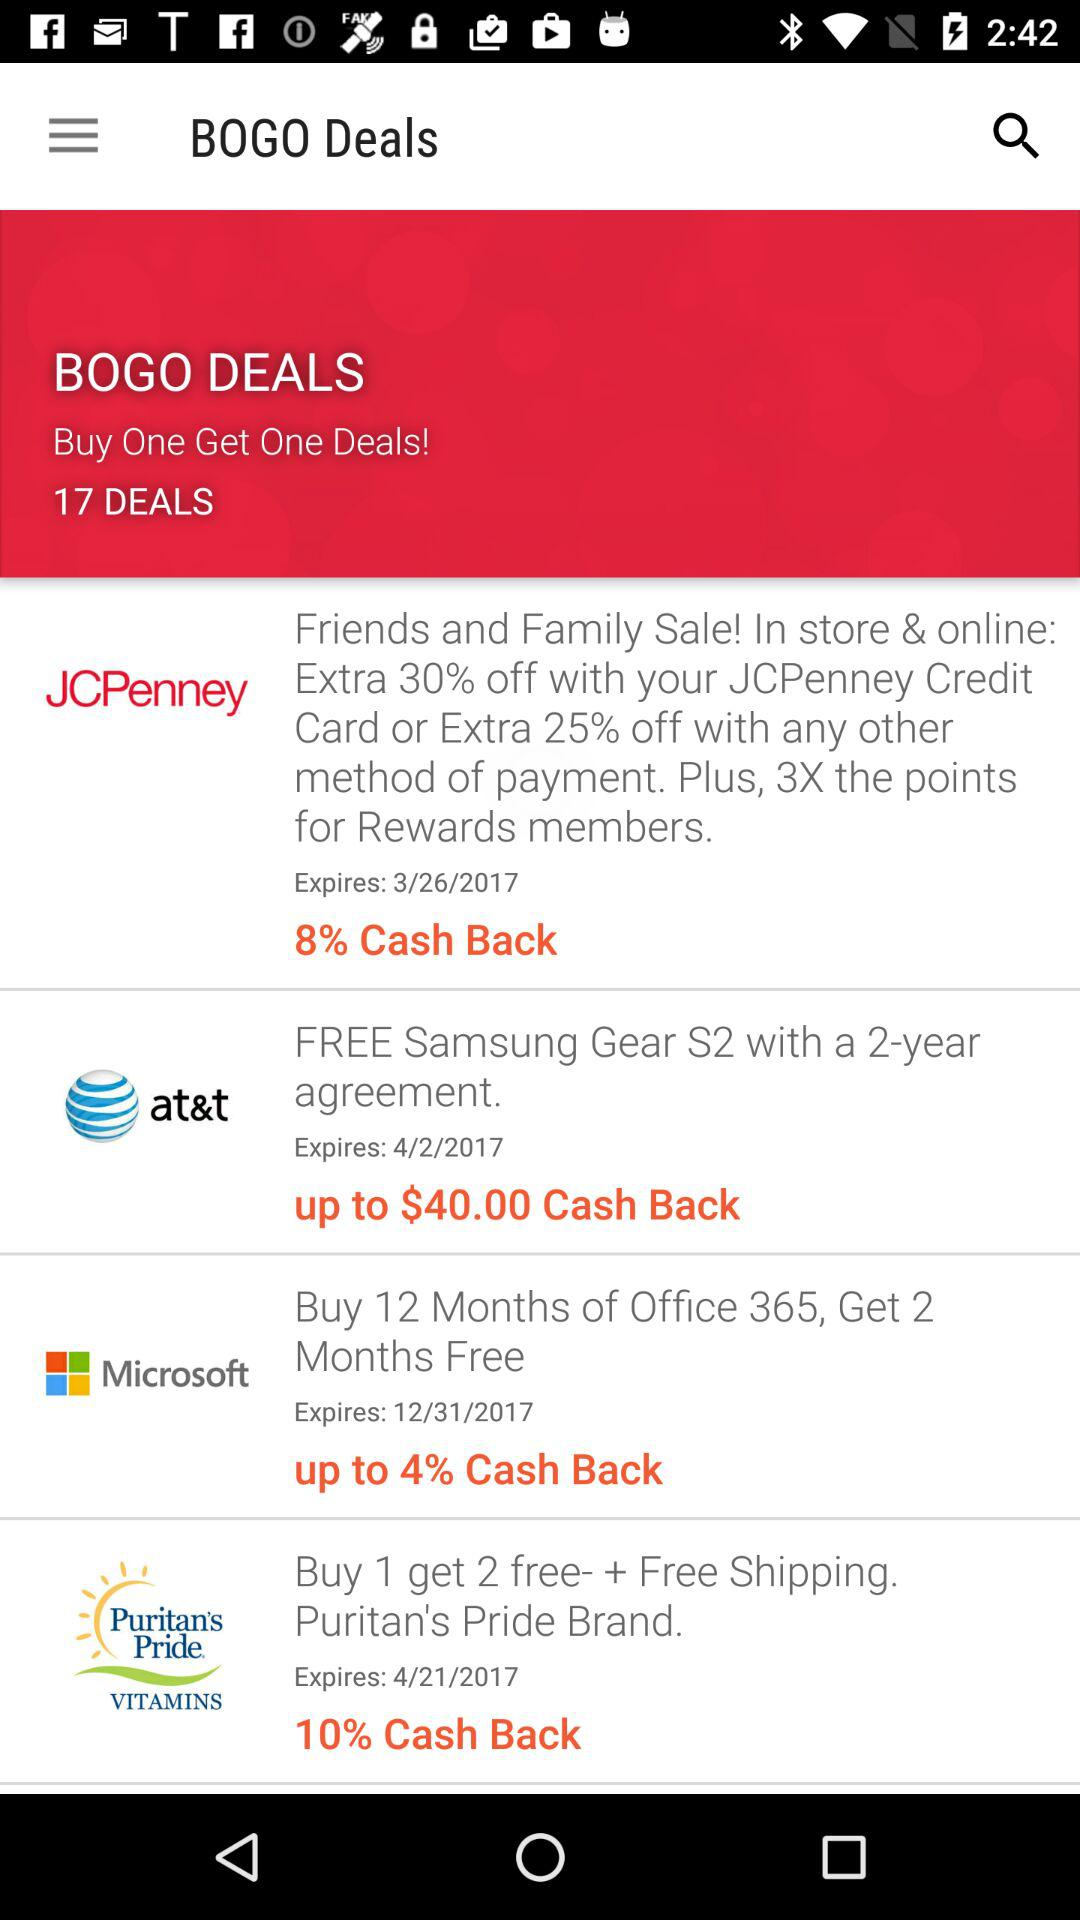Which offer in the image includes a free physical item? The AT&T offer includes a free Samsung Gear S2 with a 2-year agreement, as indicated in the image. Is this offer from AT&T still valid? If the current date is before or on the expiration date, 4/2/2017, then the offer would still be valid. 